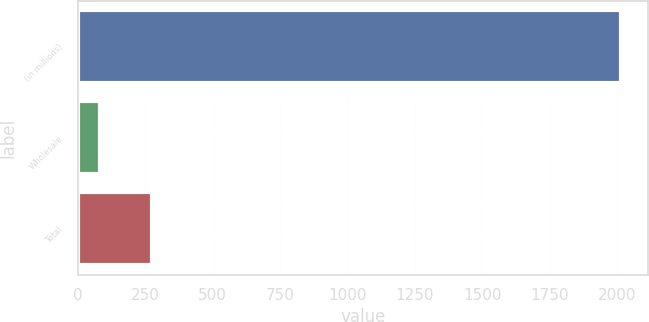Convert chart to OTSL. <chart><loc_0><loc_0><loc_500><loc_500><bar_chart><fcel>(in millions)<fcel>Wholesale<fcel>Total<nl><fcel>2013<fcel>83<fcel>276<nl></chart> 